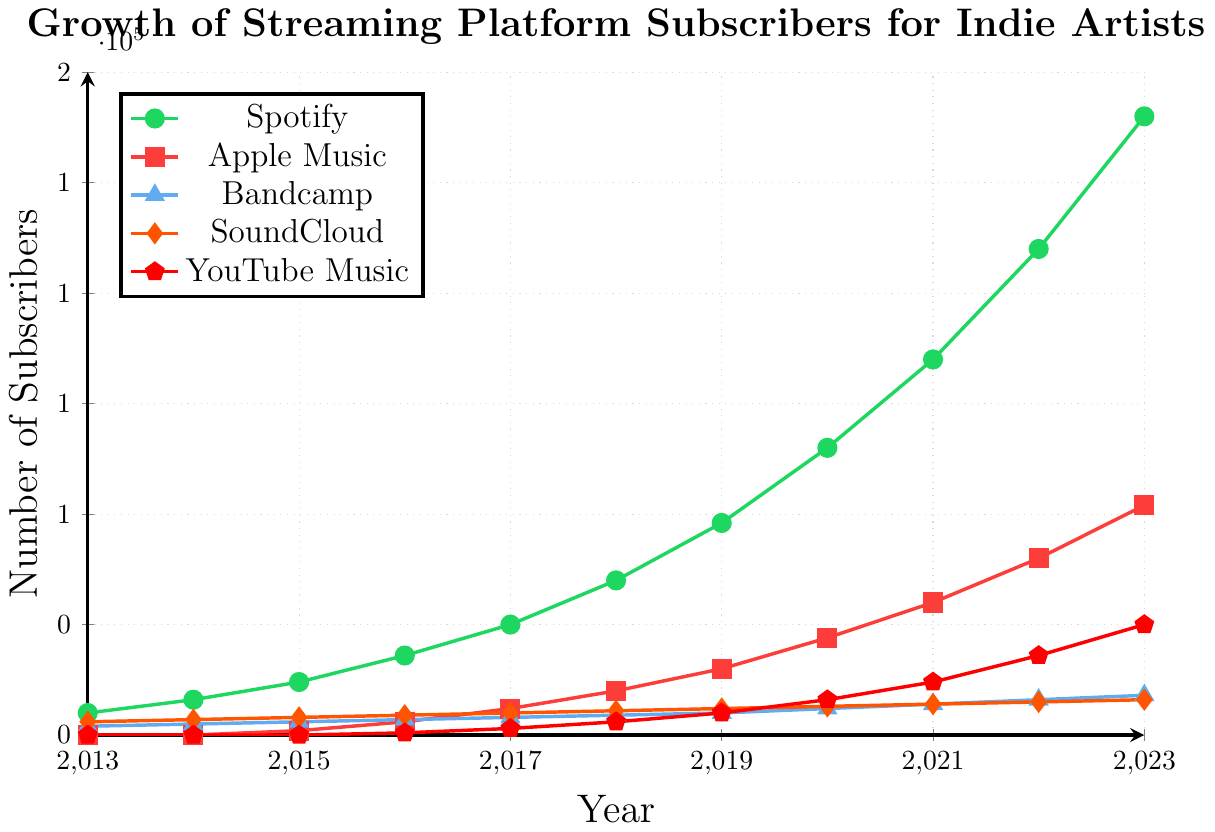Which platform had the highest number of subscribers in 2023? To find this, we need to look at the data points for the year 2023 across all platforms. Spotify had 140,000 subscribers, which is the highest among the platforms.
Answer: Spotify How many more subscribers did Spotify have in 2021 compared to Apple Music? First, look at the numbers for 2021: Spotify had 85,000 subscribers and Apple Music had 30,000. Subtract the number of Apple Music subscribers from Spotify's subscribers: 85,000 - 30,000 = 55,000.
Answer: 55,000 What is the average number of subscribers for Bandcamp from 2013 to 2023? Add all the subscriber numbers for Bandcamp from 2013 to 2023: 2000 + 2500 + 3000 + 3500 + 4000 + 4500 + 5000 + 6000 + 7000 + 8000 + 9000 = 52,500. The number of years is 11. Divide the total by the number of years: 52,500 / 11 ≈ 4772.73.
Answer: 4772.73 Which platform had the fastest growth rate in subscribers between 2019 and 2023? Calculate the growth for each platform by subtracting the 2019 subscribers from the 2023 subscribers: Spotify (140,000 - 48,000 = 92,000), Apple Music (52,000 - 15,000 = 37,000), Bandcamp (9000 - 5000 = 4000), SoundCloud (8000 - 6000 = 2000), YouTube Music (25000 - 5000 = 20000). The largest growth is for Spotify.
Answer: Spotify What was the combined number of subscribers for all platforms in 2023? Add the number of subscribers for each platform in 2023: 140,000 (Spotify) + 52,000 (Apple Music) + 9000 (Bandcamp) + 8000 (SoundCloud) + 25,000 (YouTube Music) = 234,000.
Answer: 234,000 How many more subscribers did YouTube Music gain from 2016 to 2023 compared to Apple Music? Calculate the gains for YouTube Music (25,000 - 500 = 24,500) and Apple Music (52,000 - 3000 = 49,000). Now, find the difference: 49,000 - 24,500 = 24,500.
Answer: 24,500 Which year did SoundCloud and Bandcamp have the same number of subscribers? Identify the year where SoundCloud and Bandcamp have the same number of subscribers. In 2013, SoundCloud had 3000 and Bandcamp had 2000, while in 2014 SoundCloud had 3500 and Bandcamp had 2500. None of the years show the same number of subscribers for both platforms.
Answer: None 